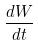<formula> <loc_0><loc_0><loc_500><loc_500>\frac { d W } { d t }</formula> 